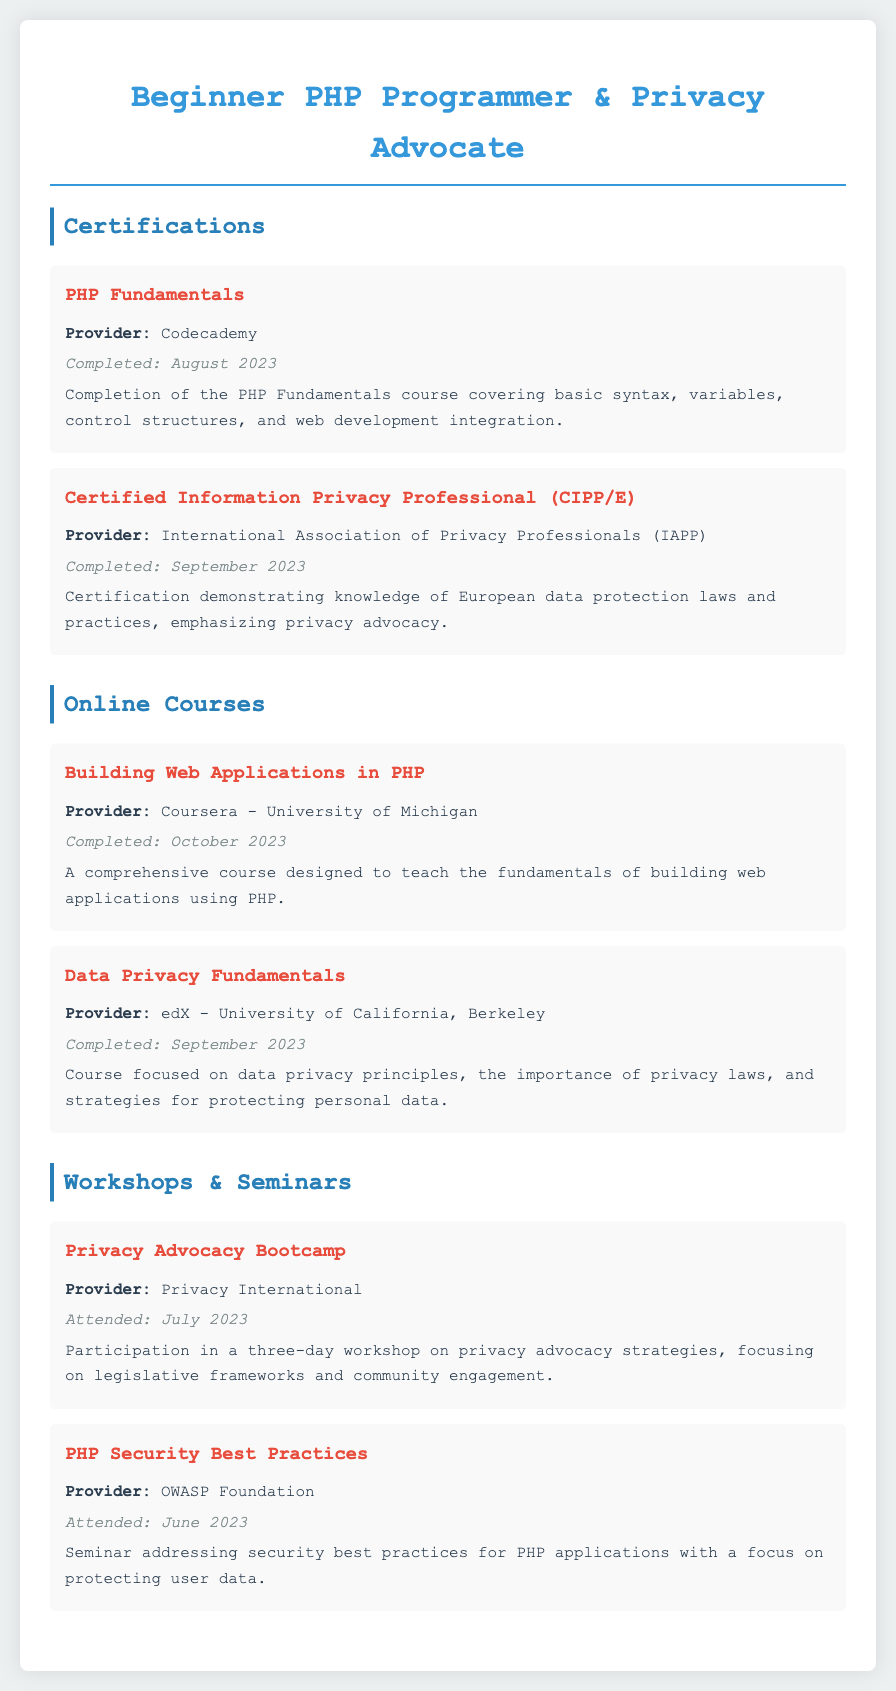What course did you complete from Codecademy? The document lists "PHP Fundamentals" as the course completed from Codecademy.
Answer: PHP Fundamentals When was the Certified Information Privacy Professional certification completed? The document states that the CIPP/E certification was completed in September 2023.
Answer: September 2023 Who provided the "Building Web Applications in PHP" course? The document specifies that this course was provided by Coursera - University of Michigan.
Answer: Coursera - University of Michigan What was the focus of the Data Privacy Fundamentals course? The document mentions that the course focused on data privacy principles and strategies for protecting personal data.
Answer: Data privacy principles and strategies for protecting personal data Which workshop or seminar was attended in July 2023? The document indicates attendance at the "Privacy Advocacy Bootcamp" in July 2023.
Answer: Privacy Advocacy Bootcamp How many days was the Privacy Advocacy Bootcamp workshop? According to the document, the workshop lasted for three days.
Answer: Three days What is the main topic of the seminar provided by the OWASP Foundation? The document states that the seminar addressed security best practices for PHP applications.
Answer: Security best practices for PHP applications What is the completion date for the Data Privacy Fundamentals course? The document specifies that this course was completed in September 2023.
Answer: September 2023 When did you complete the course titled "PHP Fundamentals"? The document states that this course was completed in August 2023.
Answer: August 2023 